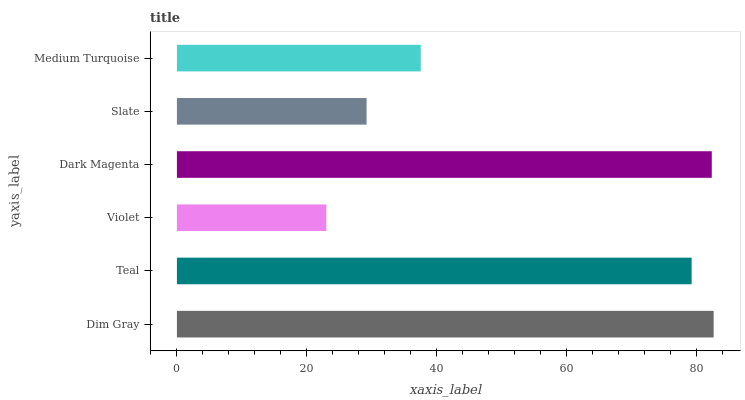Is Violet the minimum?
Answer yes or no. Yes. Is Dim Gray the maximum?
Answer yes or no. Yes. Is Teal the minimum?
Answer yes or no. No. Is Teal the maximum?
Answer yes or no. No. Is Dim Gray greater than Teal?
Answer yes or no. Yes. Is Teal less than Dim Gray?
Answer yes or no. Yes. Is Teal greater than Dim Gray?
Answer yes or no. No. Is Dim Gray less than Teal?
Answer yes or no. No. Is Teal the high median?
Answer yes or no. Yes. Is Medium Turquoise the low median?
Answer yes or no. Yes. Is Slate the high median?
Answer yes or no. No. Is Teal the low median?
Answer yes or no. No. 